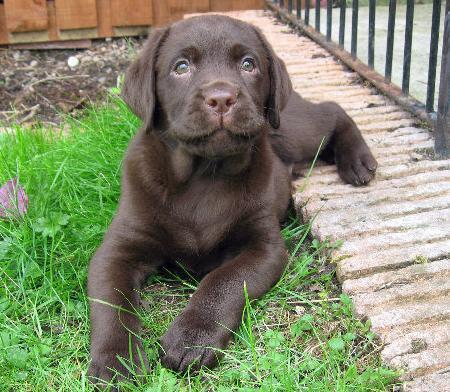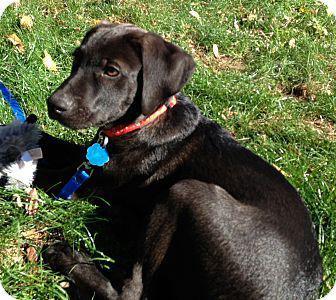The first image is the image on the left, the second image is the image on the right. Examine the images to the left and right. Is the description "There is at least one dog whose mouth is completely closed." accurate? Answer yes or no. Yes. The first image is the image on the left, the second image is the image on the right. Analyze the images presented: Is the assertion "The dog in one of the images is wearing a red collar around its neck." valid? Answer yes or no. Yes. 